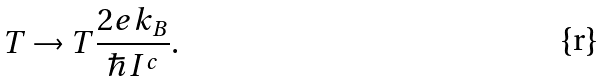Convert formula to latex. <formula><loc_0><loc_0><loc_500><loc_500>T \to T \frac { 2 e k _ { B } } { \hbar { I } ^ { c } } .</formula> 